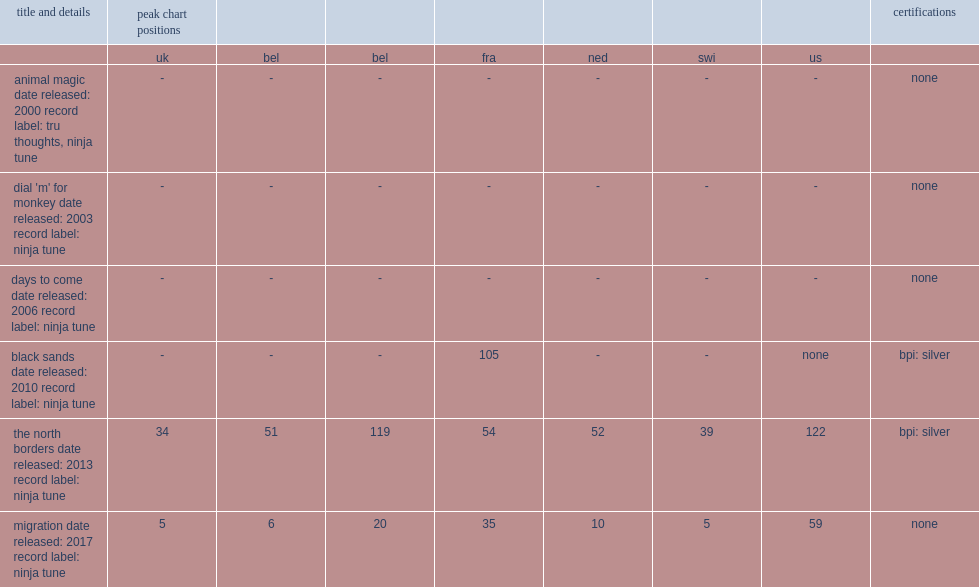What was the peak chart position on the uk of the north borders? 34.0. 